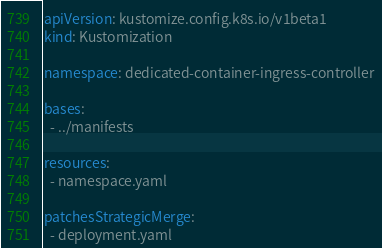Convert code to text. <code><loc_0><loc_0><loc_500><loc_500><_YAML_>apiVersion: kustomize.config.k8s.io/v1beta1
kind: Kustomization

namespace: dedicated-container-ingress-controller

bases:
  - ../manifests

resources:
  - namespace.yaml

patchesStrategicMerge:
  - deployment.yaml
</code> 